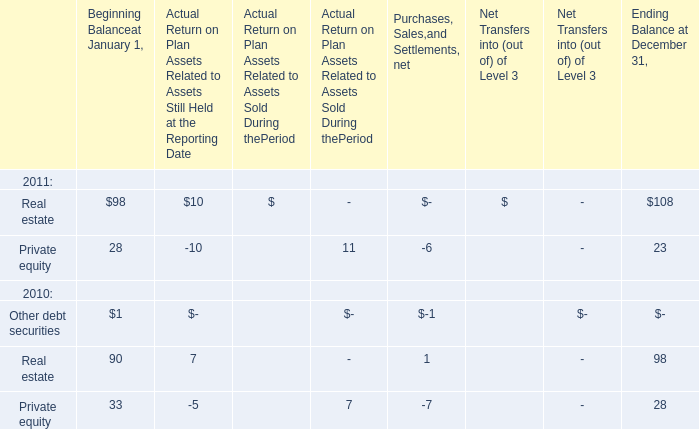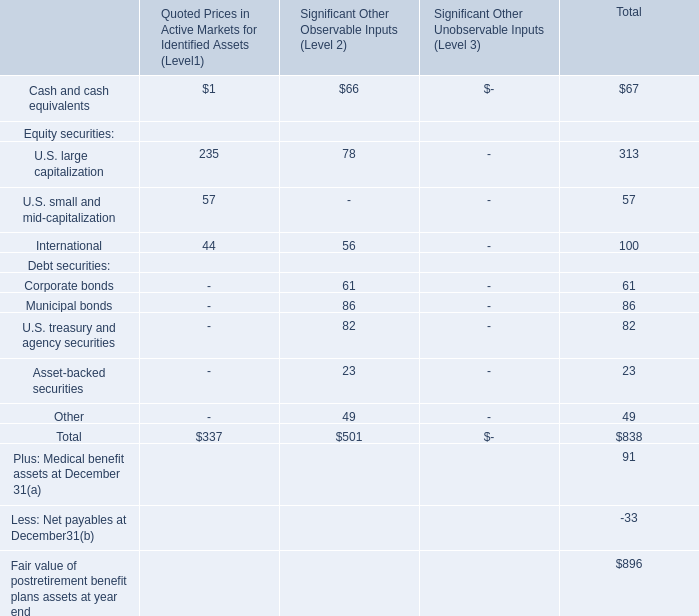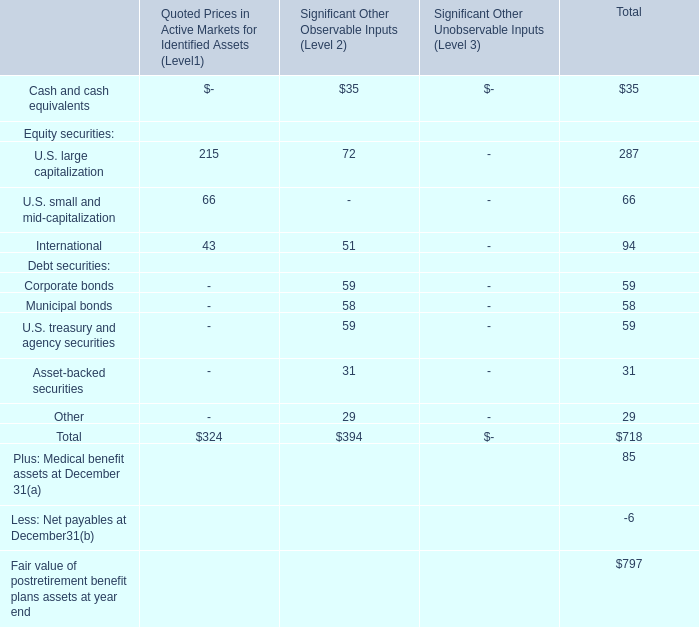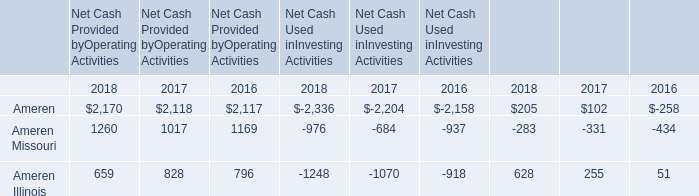based on the current amount of annual amortization , how many years will it take to fully amortize the goodwill balance at december 31 , 2001? 
Computations: ((3.2 * 1000) / 62)
Answer: 51.6129. 